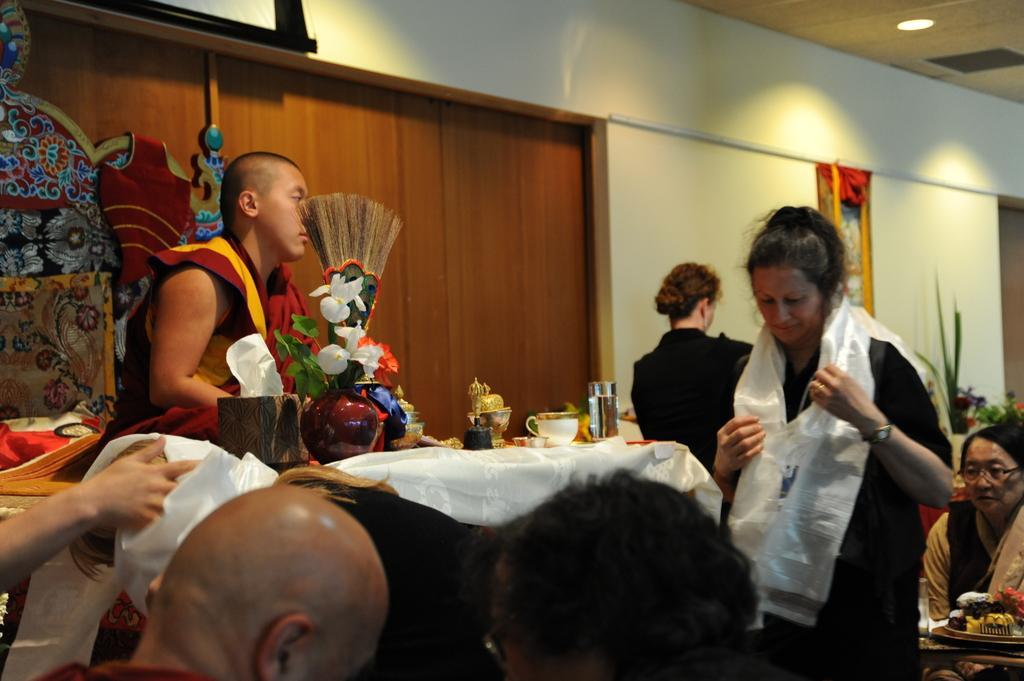In one or two sentences, can you explain what this image depicts? As we can see in the image there is a white color wall, few people sitting on chairs and there is a table. On table there is a flower flask, cup and glass. 